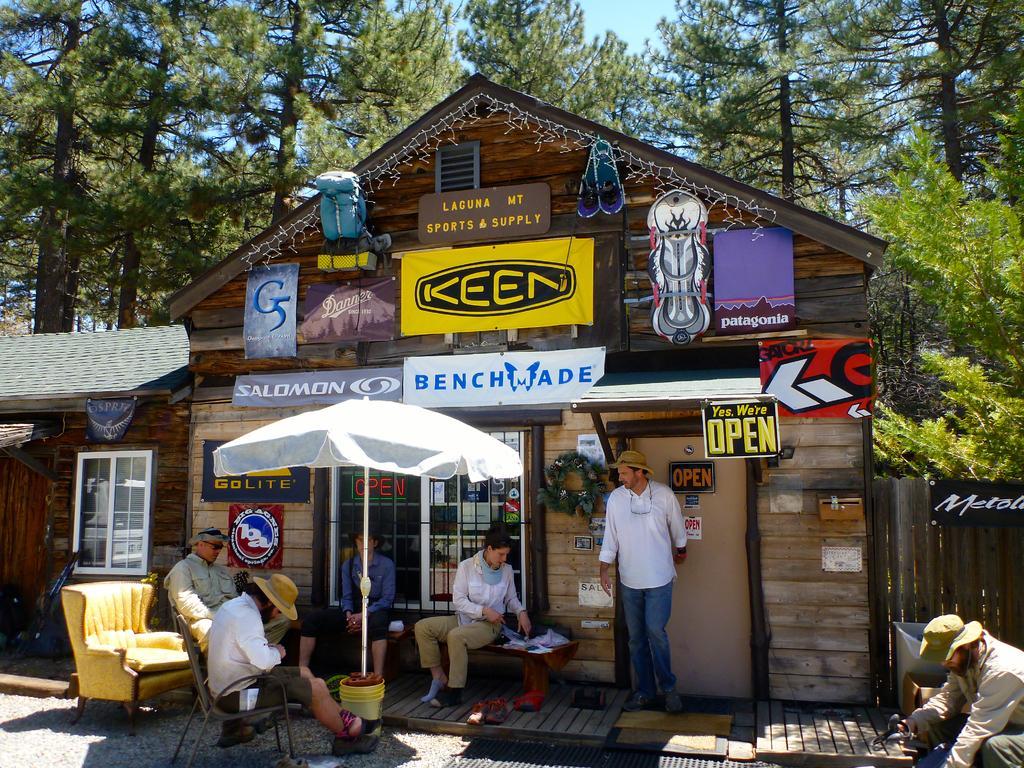In one or two sentences, can you explain what this image depicts? In this image there are group of people in front of the building, in the middle there is an umbrella and there is a window at the left side of the image. At the back side of the building there are trees and at the top there is a sky. 